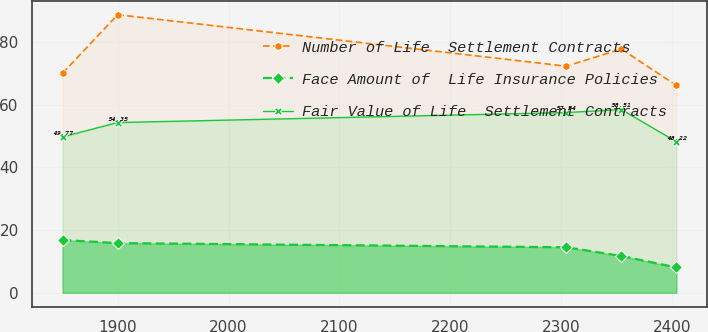Convert chart. <chart><loc_0><loc_0><loc_500><loc_500><line_chart><ecel><fcel>Number of Life  Settlement Contracts<fcel>Face Amount of  Life Insurance Policies<fcel>Fair Value of Life  Settlement Contracts<nl><fcel>1850.18<fcel>70.09<fcel>16.84<fcel>49.77<nl><fcel>1899.88<fcel>88.79<fcel>15.87<fcel>54.35<nl><fcel>2304.59<fcel>72.35<fcel>14.53<fcel>57.54<nl><fcel>2354.29<fcel>77.84<fcel>11.75<fcel>58.51<nl><fcel>2403.99<fcel>66.19<fcel>8.08<fcel>48.22<nl></chart> 